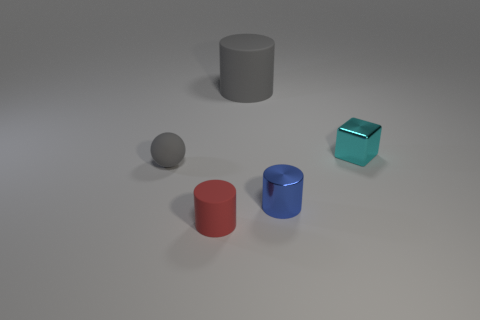Add 4 gray spheres. How many objects exist? 9 Subtract all blocks. How many objects are left? 4 Add 2 red matte cylinders. How many red matte cylinders exist? 3 Subtract 0 purple balls. How many objects are left? 5 Subtract all gray matte spheres. Subtract all things. How many objects are left? 3 Add 2 blue shiny cylinders. How many blue shiny cylinders are left? 3 